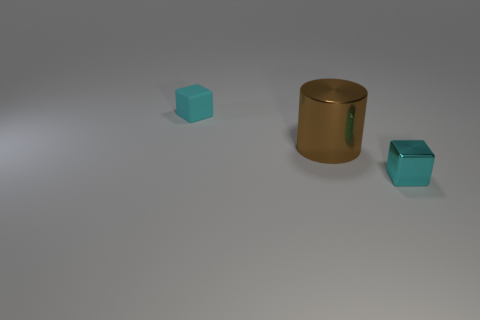Is there any other thing that has the same size as the cylinder?
Provide a succinct answer. No. There is a thing that is in front of the tiny cyan matte object and to the left of the cyan metallic object; what is its material?
Keep it short and to the point. Metal. How many cyan metallic cubes are the same size as the matte cube?
Make the answer very short. 1. What number of metallic things are cubes or large brown cylinders?
Give a very brief answer. 2. What is the material of the big brown thing?
Your answer should be very brief. Metal. How many small blocks are right of the big metal cylinder?
Ensure brevity in your answer.  1. Does the cyan cube that is in front of the large object have the same material as the big brown cylinder?
Provide a short and direct response. Yes. How many large purple metallic objects are the same shape as the tiny metallic thing?
Make the answer very short. 0. What number of large objects are either purple metal balls or cyan cubes?
Give a very brief answer. 0. Does the small matte cube to the left of the cyan metallic cube have the same color as the big cylinder?
Your answer should be compact. No. 